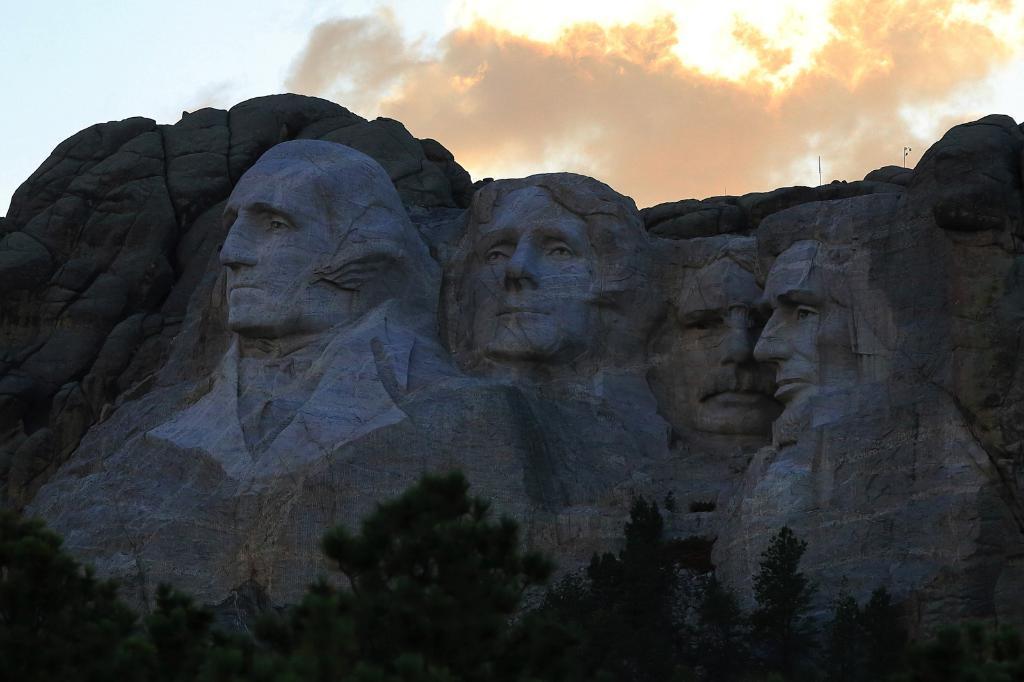Can you describe this image briefly? In this image I can see the carving of the persons faces on the rock and I can see trees in green color and sky is in white and blue color. 